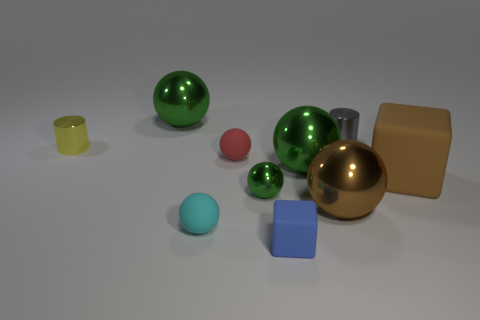There is a cyan thing that is made of the same material as the blue cube; what shape is it?
Your answer should be very brief. Sphere. Is the material of the tiny yellow cylinder the same as the big green sphere in front of the small yellow metallic cylinder?
Ensure brevity in your answer.  Yes. Is there a small thing in front of the small cylinder that is to the right of the large brown metal object?
Ensure brevity in your answer.  Yes. There is a small red thing that is the same shape as the cyan thing; what is it made of?
Keep it short and to the point. Rubber. What number of matte spheres are left of the big green thing right of the blue rubber thing?
Your answer should be very brief. 2. Is there anything else that is the same color as the small rubber block?
Your response must be concise. No. How many things are either blue cubes or small cylinders on the right side of the big brown sphere?
Offer a very short reply. 2. There is a big green sphere that is to the right of the large green shiny thing left of the matte block on the left side of the gray shiny cylinder; what is its material?
Make the answer very short. Metal. The yellow cylinder that is made of the same material as the tiny gray object is what size?
Ensure brevity in your answer.  Small. What is the color of the cylinder that is right of the big thing behind the red matte sphere?
Keep it short and to the point. Gray. 